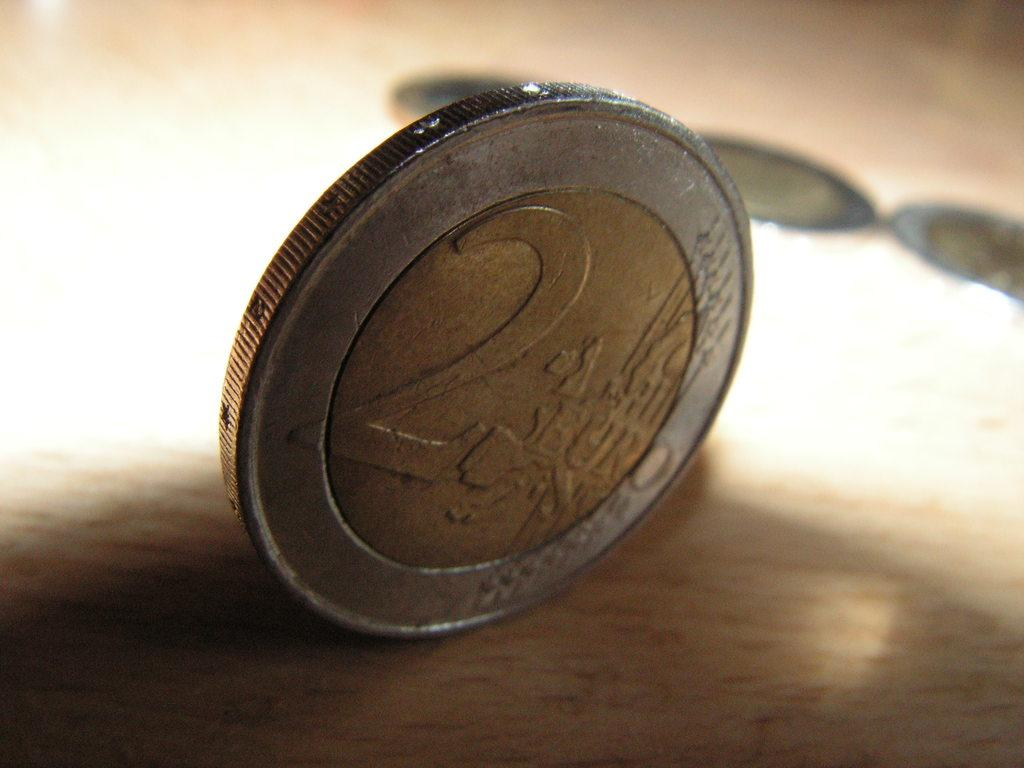<image>
Give a short and clear explanation of the subsequent image. 2 Euro is stamped into the face of this coin. 